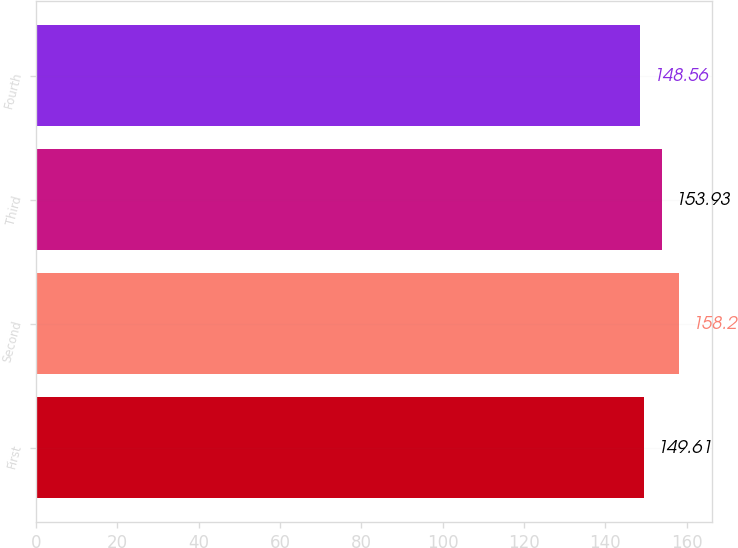<chart> <loc_0><loc_0><loc_500><loc_500><bar_chart><fcel>First<fcel>Second<fcel>Third<fcel>Fourth<nl><fcel>149.61<fcel>158.2<fcel>153.93<fcel>148.56<nl></chart> 